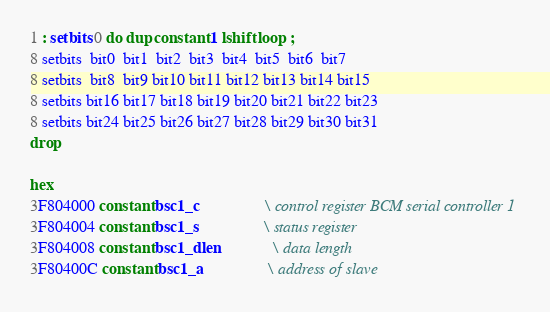<code> <loc_0><loc_0><loc_500><loc_500><_Forth_>1 : setbits 0 do dup constant 1 lshift loop ;
8 setbits  bit0  bit1  bit2  bit3  bit4  bit5  bit6  bit7
8 setbits  bit8  bit9 bit10 bit11 bit12 bit13 bit14 bit15
8 setbits bit16 bit17 bit18 bit19 bit20 bit21 bit22 bit23
8 setbits bit24 bit25 bit26 bit27 bit28 bit29 bit30 bit31
drop

hex
3F804000 constant bsc1_c                \ control register BCM serial controller 1
3F804004 constant bsc1_s                \ status register
3F804008 constant bsc1_dlen             \ data length
3F80400C constant bsc1_a                \ address of slave</code> 